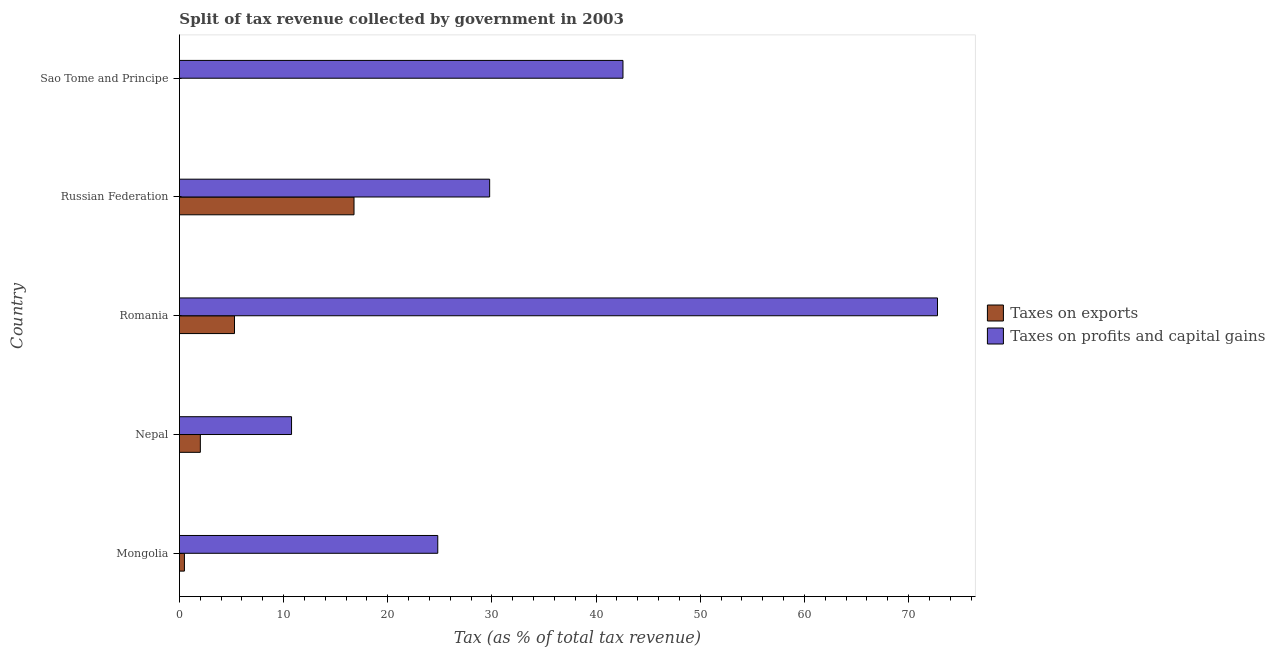Are the number of bars per tick equal to the number of legend labels?
Ensure brevity in your answer.  Yes. How many bars are there on the 2nd tick from the top?
Provide a succinct answer. 2. How many bars are there on the 5th tick from the bottom?
Offer a very short reply. 2. What is the label of the 2nd group of bars from the top?
Your answer should be very brief. Russian Federation. In how many cases, is the number of bars for a given country not equal to the number of legend labels?
Provide a short and direct response. 0. What is the percentage of revenue obtained from taxes on profits and capital gains in Nepal?
Provide a succinct answer. 10.77. Across all countries, what is the maximum percentage of revenue obtained from taxes on exports?
Provide a succinct answer. 16.76. Across all countries, what is the minimum percentage of revenue obtained from taxes on profits and capital gains?
Give a very brief answer. 10.77. In which country was the percentage of revenue obtained from taxes on exports maximum?
Provide a short and direct response. Russian Federation. In which country was the percentage of revenue obtained from taxes on profits and capital gains minimum?
Offer a terse response. Nepal. What is the total percentage of revenue obtained from taxes on exports in the graph?
Offer a very short reply. 24.54. What is the difference between the percentage of revenue obtained from taxes on exports in Russian Federation and that in Sao Tome and Principe?
Your answer should be very brief. 16.76. What is the difference between the percentage of revenue obtained from taxes on exports in Mongolia and the percentage of revenue obtained from taxes on profits and capital gains in Nepal?
Provide a short and direct response. -10.28. What is the average percentage of revenue obtained from taxes on profits and capital gains per country?
Ensure brevity in your answer.  36.15. What is the difference between the percentage of revenue obtained from taxes on exports and percentage of revenue obtained from taxes on profits and capital gains in Sao Tome and Principe?
Your response must be concise. -42.58. In how many countries, is the percentage of revenue obtained from taxes on profits and capital gains greater than 58 %?
Provide a succinct answer. 1. What is the ratio of the percentage of revenue obtained from taxes on exports in Mongolia to that in Russian Federation?
Provide a short and direct response. 0.03. Is the percentage of revenue obtained from taxes on exports in Nepal less than that in Romania?
Make the answer very short. Yes. Is the difference between the percentage of revenue obtained from taxes on profits and capital gains in Mongolia and Nepal greater than the difference between the percentage of revenue obtained from taxes on exports in Mongolia and Nepal?
Keep it short and to the point. Yes. What is the difference between the highest and the second highest percentage of revenue obtained from taxes on exports?
Offer a very short reply. 11.47. What is the difference between the highest and the lowest percentage of revenue obtained from taxes on exports?
Your answer should be compact. 16.76. Is the sum of the percentage of revenue obtained from taxes on profits and capital gains in Romania and Sao Tome and Principe greater than the maximum percentage of revenue obtained from taxes on exports across all countries?
Ensure brevity in your answer.  Yes. What does the 1st bar from the top in Nepal represents?
Give a very brief answer. Taxes on profits and capital gains. What does the 1st bar from the bottom in Nepal represents?
Your answer should be compact. Taxes on exports. How many bars are there?
Offer a very short reply. 10. What is the difference between two consecutive major ticks on the X-axis?
Keep it short and to the point. 10. Are the values on the major ticks of X-axis written in scientific E-notation?
Ensure brevity in your answer.  No. Does the graph contain any zero values?
Your response must be concise. No. Does the graph contain grids?
Keep it short and to the point. No. Where does the legend appear in the graph?
Provide a succinct answer. Center right. How many legend labels are there?
Make the answer very short. 2. How are the legend labels stacked?
Your answer should be very brief. Vertical. What is the title of the graph?
Keep it short and to the point. Split of tax revenue collected by government in 2003. Does "Time to export" appear as one of the legend labels in the graph?
Ensure brevity in your answer.  No. What is the label or title of the X-axis?
Your answer should be very brief. Tax (as % of total tax revenue). What is the Tax (as % of total tax revenue) of Taxes on exports in Mongolia?
Keep it short and to the point. 0.48. What is the Tax (as % of total tax revenue) in Taxes on profits and capital gains in Mongolia?
Offer a terse response. 24.8. What is the Tax (as % of total tax revenue) in Taxes on exports in Nepal?
Your response must be concise. 2.01. What is the Tax (as % of total tax revenue) of Taxes on profits and capital gains in Nepal?
Offer a very short reply. 10.77. What is the Tax (as % of total tax revenue) in Taxes on exports in Romania?
Offer a very short reply. 5.29. What is the Tax (as % of total tax revenue) of Taxes on profits and capital gains in Romania?
Offer a terse response. 72.78. What is the Tax (as % of total tax revenue) in Taxes on exports in Russian Federation?
Your answer should be very brief. 16.76. What is the Tax (as % of total tax revenue) of Taxes on profits and capital gains in Russian Federation?
Ensure brevity in your answer.  29.79. What is the Tax (as % of total tax revenue) of Taxes on exports in Sao Tome and Principe?
Provide a short and direct response. 0. What is the Tax (as % of total tax revenue) in Taxes on profits and capital gains in Sao Tome and Principe?
Offer a very short reply. 42.58. Across all countries, what is the maximum Tax (as % of total tax revenue) of Taxes on exports?
Your answer should be very brief. 16.76. Across all countries, what is the maximum Tax (as % of total tax revenue) in Taxes on profits and capital gains?
Your answer should be very brief. 72.78. Across all countries, what is the minimum Tax (as % of total tax revenue) in Taxes on exports?
Ensure brevity in your answer.  0. Across all countries, what is the minimum Tax (as % of total tax revenue) of Taxes on profits and capital gains?
Ensure brevity in your answer.  10.77. What is the total Tax (as % of total tax revenue) of Taxes on exports in the graph?
Your answer should be very brief. 24.54. What is the total Tax (as % of total tax revenue) in Taxes on profits and capital gains in the graph?
Ensure brevity in your answer.  180.72. What is the difference between the Tax (as % of total tax revenue) in Taxes on exports in Mongolia and that in Nepal?
Your answer should be very brief. -1.53. What is the difference between the Tax (as % of total tax revenue) of Taxes on profits and capital gains in Mongolia and that in Nepal?
Keep it short and to the point. 14.04. What is the difference between the Tax (as % of total tax revenue) of Taxes on exports in Mongolia and that in Romania?
Make the answer very short. -4.81. What is the difference between the Tax (as % of total tax revenue) in Taxes on profits and capital gains in Mongolia and that in Romania?
Offer a terse response. -47.98. What is the difference between the Tax (as % of total tax revenue) in Taxes on exports in Mongolia and that in Russian Federation?
Your response must be concise. -16.28. What is the difference between the Tax (as % of total tax revenue) of Taxes on profits and capital gains in Mongolia and that in Russian Federation?
Ensure brevity in your answer.  -4.98. What is the difference between the Tax (as % of total tax revenue) in Taxes on exports in Mongolia and that in Sao Tome and Principe?
Keep it short and to the point. 0.48. What is the difference between the Tax (as % of total tax revenue) of Taxes on profits and capital gains in Mongolia and that in Sao Tome and Principe?
Give a very brief answer. -17.78. What is the difference between the Tax (as % of total tax revenue) in Taxes on exports in Nepal and that in Romania?
Offer a terse response. -3.28. What is the difference between the Tax (as % of total tax revenue) of Taxes on profits and capital gains in Nepal and that in Romania?
Your answer should be very brief. -62.02. What is the difference between the Tax (as % of total tax revenue) in Taxes on exports in Nepal and that in Russian Federation?
Make the answer very short. -14.75. What is the difference between the Tax (as % of total tax revenue) of Taxes on profits and capital gains in Nepal and that in Russian Federation?
Make the answer very short. -19.02. What is the difference between the Tax (as % of total tax revenue) in Taxes on exports in Nepal and that in Sao Tome and Principe?
Keep it short and to the point. 2.01. What is the difference between the Tax (as % of total tax revenue) of Taxes on profits and capital gains in Nepal and that in Sao Tome and Principe?
Offer a terse response. -31.82. What is the difference between the Tax (as % of total tax revenue) in Taxes on exports in Romania and that in Russian Federation?
Provide a succinct answer. -11.47. What is the difference between the Tax (as % of total tax revenue) of Taxes on profits and capital gains in Romania and that in Russian Federation?
Make the answer very short. 43. What is the difference between the Tax (as % of total tax revenue) in Taxes on exports in Romania and that in Sao Tome and Principe?
Provide a short and direct response. 5.29. What is the difference between the Tax (as % of total tax revenue) in Taxes on profits and capital gains in Romania and that in Sao Tome and Principe?
Provide a short and direct response. 30.2. What is the difference between the Tax (as % of total tax revenue) of Taxes on exports in Russian Federation and that in Sao Tome and Principe?
Give a very brief answer. 16.76. What is the difference between the Tax (as % of total tax revenue) of Taxes on profits and capital gains in Russian Federation and that in Sao Tome and Principe?
Your answer should be very brief. -12.8. What is the difference between the Tax (as % of total tax revenue) in Taxes on exports in Mongolia and the Tax (as % of total tax revenue) in Taxes on profits and capital gains in Nepal?
Offer a terse response. -10.28. What is the difference between the Tax (as % of total tax revenue) of Taxes on exports in Mongolia and the Tax (as % of total tax revenue) of Taxes on profits and capital gains in Romania?
Your response must be concise. -72.3. What is the difference between the Tax (as % of total tax revenue) in Taxes on exports in Mongolia and the Tax (as % of total tax revenue) in Taxes on profits and capital gains in Russian Federation?
Your response must be concise. -29.3. What is the difference between the Tax (as % of total tax revenue) of Taxes on exports in Mongolia and the Tax (as % of total tax revenue) of Taxes on profits and capital gains in Sao Tome and Principe?
Your response must be concise. -42.1. What is the difference between the Tax (as % of total tax revenue) of Taxes on exports in Nepal and the Tax (as % of total tax revenue) of Taxes on profits and capital gains in Romania?
Offer a terse response. -70.77. What is the difference between the Tax (as % of total tax revenue) in Taxes on exports in Nepal and the Tax (as % of total tax revenue) in Taxes on profits and capital gains in Russian Federation?
Your answer should be very brief. -27.78. What is the difference between the Tax (as % of total tax revenue) of Taxes on exports in Nepal and the Tax (as % of total tax revenue) of Taxes on profits and capital gains in Sao Tome and Principe?
Provide a short and direct response. -40.58. What is the difference between the Tax (as % of total tax revenue) in Taxes on exports in Romania and the Tax (as % of total tax revenue) in Taxes on profits and capital gains in Russian Federation?
Your response must be concise. -24.5. What is the difference between the Tax (as % of total tax revenue) of Taxes on exports in Romania and the Tax (as % of total tax revenue) of Taxes on profits and capital gains in Sao Tome and Principe?
Keep it short and to the point. -37.3. What is the difference between the Tax (as % of total tax revenue) in Taxes on exports in Russian Federation and the Tax (as % of total tax revenue) in Taxes on profits and capital gains in Sao Tome and Principe?
Your answer should be compact. -25.82. What is the average Tax (as % of total tax revenue) in Taxes on exports per country?
Provide a succinct answer. 4.91. What is the average Tax (as % of total tax revenue) of Taxes on profits and capital gains per country?
Offer a very short reply. 36.14. What is the difference between the Tax (as % of total tax revenue) of Taxes on exports and Tax (as % of total tax revenue) of Taxes on profits and capital gains in Mongolia?
Offer a very short reply. -24.32. What is the difference between the Tax (as % of total tax revenue) of Taxes on exports and Tax (as % of total tax revenue) of Taxes on profits and capital gains in Nepal?
Your answer should be compact. -8.76. What is the difference between the Tax (as % of total tax revenue) in Taxes on exports and Tax (as % of total tax revenue) in Taxes on profits and capital gains in Romania?
Offer a very short reply. -67.49. What is the difference between the Tax (as % of total tax revenue) in Taxes on exports and Tax (as % of total tax revenue) in Taxes on profits and capital gains in Russian Federation?
Keep it short and to the point. -13.02. What is the difference between the Tax (as % of total tax revenue) in Taxes on exports and Tax (as % of total tax revenue) in Taxes on profits and capital gains in Sao Tome and Principe?
Your answer should be very brief. -42.58. What is the ratio of the Tax (as % of total tax revenue) in Taxes on exports in Mongolia to that in Nepal?
Your response must be concise. 0.24. What is the ratio of the Tax (as % of total tax revenue) in Taxes on profits and capital gains in Mongolia to that in Nepal?
Your answer should be very brief. 2.3. What is the ratio of the Tax (as % of total tax revenue) in Taxes on exports in Mongolia to that in Romania?
Ensure brevity in your answer.  0.09. What is the ratio of the Tax (as % of total tax revenue) in Taxes on profits and capital gains in Mongolia to that in Romania?
Offer a terse response. 0.34. What is the ratio of the Tax (as % of total tax revenue) in Taxes on exports in Mongolia to that in Russian Federation?
Give a very brief answer. 0.03. What is the ratio of the Tax (as % of total tax revenue) of Taxes on profits and capital gains in Mongolia to that in Russian Federation?
Offer a terse response. 0.83. What is the ratio of the Tax (as % of total tax revenue) in Taxes on exports in Mongolia to that in Sao Tome and Principe?
Provide a short and direct response. 460.55. What is the ratio of the Tax (as % of total tax revenue) of Taxes on profits and capital gains in Mongolia to that in Sao Tome and Principe?
Your response must be concise. 0.58. What is the ratio of the Tax (as % of total tax revenue) of Taxes on exports in Nepal to that in Romania?
Your answer should be compact. 0.38. What is the ratio of the Tax (as % of total tax revenue) in Taxes on profits and capital gains in Nepal to that in Romania?
Offer a very short reply. 0.15. What is the ratio of the Tax (as % of total tax revenue) of Taxes on exports in Nepal to that in Russian Federation?
Give a very brief answer. 0.12. What is the ratio of the Tax (as % of total tax revenue) of Taxes on profits and capital gains in Nepal to that in Russian Federation?
Offer a very short reply. 0.36. What is the ratio of the Tax (as % of total tax revenue) of Taxes on exports in Nepal to that in Sao Tome and Principe?
Provide a short and direct response. 1922.36. What is the ratio of the Tax (as % of total tax revenue) of Taxes on profits and capital gains in Nepal to that in Sao Tome and Principe?
Give a very brief answer. 0.25. What is the ratio of the Tax (as % of total tax revenue) of Taxes on exports in Romania to that in Russian Federation?
Provide a succinct answer. 0.32. What is the ratio of the Tax (as % of total tax revenue) in Taxes on profits and capital gains in Romania to that in Russian Federation?
Provide a short and direct response. 2.44. What is the ratio of the Tax (as % of total tax revenue) of Taxes on exports in Romania to that in Sao Tome and Principe?
Ensure brevity in your answer.  5060.34. What is the ratio of the Tax (as % of total tax revenue) of Taxes on profits and capital gains in Romania to that in Sao Tome and Principe?
Offer a terse response. 1.71. What is the ratio of the Tax (as % of total tax revenue) in Taxes on exports in Russian Federation to that in Sao Tome and Principe?
Your answer should be compact. 1.60e+04. What is the ratio of the Tax (as % of total tax revenue) in Taxes on profits and capital gains in Russian Federation to that in Sao Tome and Principe?
Offer a very short reply. 0.7. What is the difference between the highest and the second highest Tax (as % of total tax revenue) of Taxes on exports?
Your answer should be compact. 11.47. What is the difference between the highest and the second highest Tax (as % of total tax revenue) of Taxes on profits and capital gains?
Ensure brevity in your answer.  30.2. What is the difference between the highest and the lowest Tax (as % of total tax revenue) in Taxes on exports?
Your answer should be very brief. 16.76. What is the difference between the highest and the lowest Tax (as % of total tax revenue) in Taxes on profits and capital gains?
Offer a terse response. 62.02. 